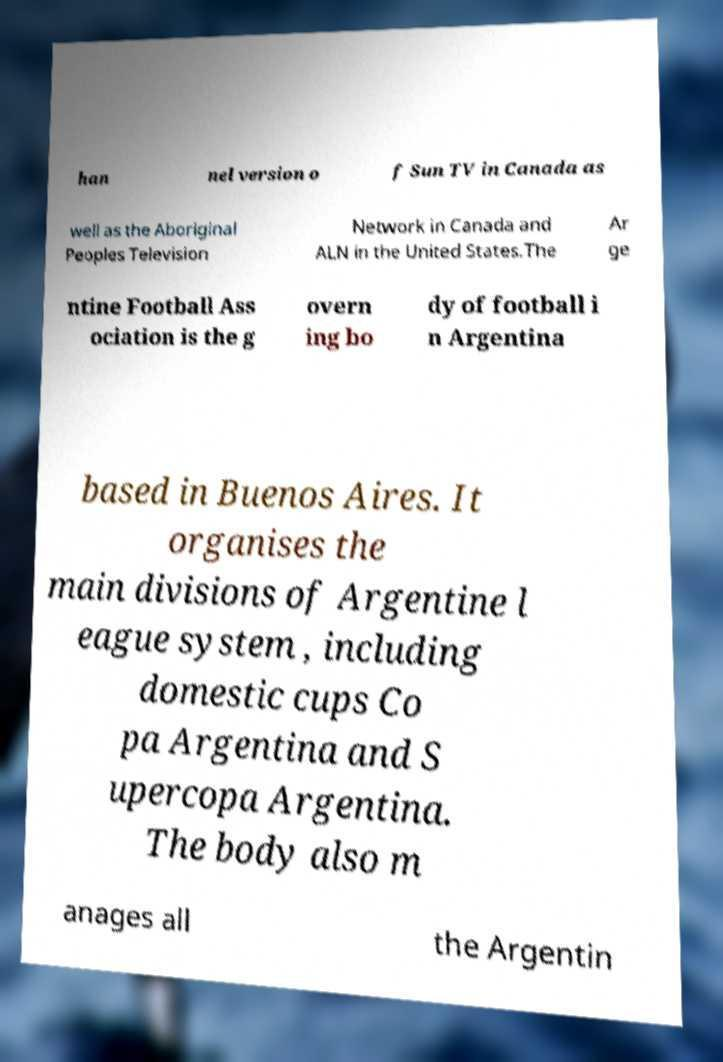For documentation purposes, I need the text within this image transcribed. Could you provide that? han nel version o f Sun TV in Canada as well as the Aboriginal Peoples Television Network in Canada and ALN in the United States.The Ar ge ntine Football Ass ociation is the g overn ing bo dy of football i n Argentina based in Buenos Aires. It organises the main divisions of Argentine l eague system , including domestic cups Co pa Argentina and S upercopa Argentina. The body also m anages all the Argentin 